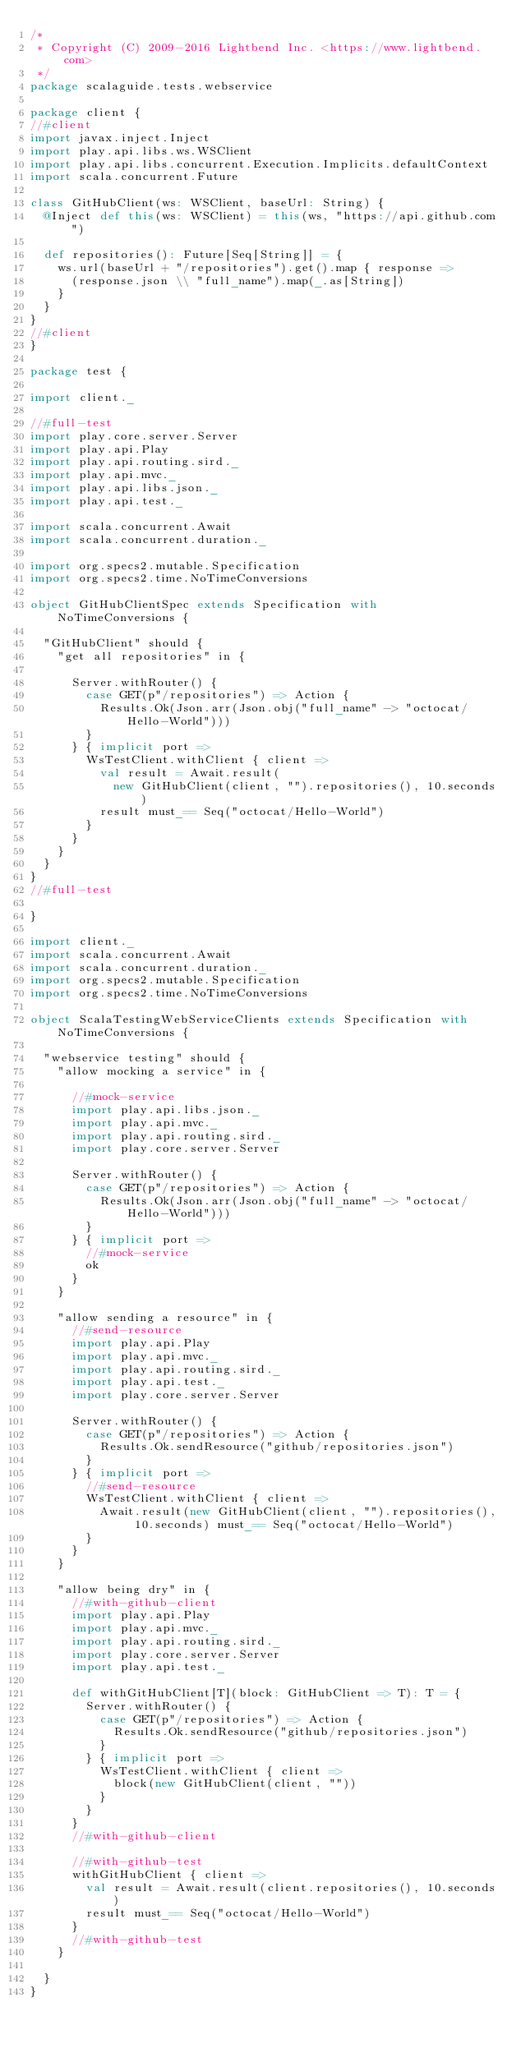<code> <loc_0><loc_0><loc_500><loc_500><_Scala_>/*
 * Copyright (C) 2009-2016 Lightbend Inc. <https://www.lightbend.com>
 */
package scalaguide.tests.webservice

package client {
//#client
import javax.inject.Inject
import play.api.libs.ws.WSClient
import play.api.libs.concurrent.Execution.Implicits.defaultContext
import scala.concurrent.Future

class GitHubClient(ws: WSClient, baseUrl: String) {
  @Inject def this(ws: WSClient) = this(ws, "https://api.github.com")

  def repositories(): Future[Seq[String]] = {
    ws.url(baseUrl + "/repositories").get().map { response =>
      (response.json \\ "full_name").map(_.as[String])
    }
  }
}
//#client
}

package test {

import client._

//#full-test
import play.core.server.Server
import play.api.Play
import play.api.routing.sird._
import play.api.mvc._
import play.api.libs.json._
import play.api.test._

import scala.concurrent.Await
import scala.concurrent.duration._

import org.specs2.mutable.Specification
import org.specs2.time.NoTimeConversions

object GitHubClientSpec extends Specification with NoTimeConversions {

  "GitHubClient" should {
    "get all repositories" in {

      Server.withRouter() {
        case GET(p"/repositories") => Action {
          Results.Ok(Json.arr(Json.obj("full_name" -> "octocat/Hello-World")))
        }
      } { implicit port =>
        WsTestClient.withClient { client =>
          val result = Await.result(
            new GitHubClient(client, "").repositories(), 10.seconds)
          result must_== Seq("octocat/Hello-World")
        }
      }
    }
  }
}
//#full-test

}

import client._
import scala.concurrent.Await
import scala.concurrent.duration._
import org.specs2.mutable.Specification
import org.specs2.time.NoTimeConversions

object ScalaTestingWebServiceClients extends Specification with NoTimeConversions {

  "webservice testing" should {
    "allow mocking a service" in {

      //#mock-service
      import play.api.libs.json._
      import play.api.mvc._
      import play.api.routing.sird._
      import play.core.server.Server

      Server.withRouter() {
        case GET(p"/repositories") => Action {
          Results.Ok(Json.arr(Json.obj("full_name" -> "octocat/Hello-World")))
        }
      } { implicit port =>
        //#mock-service
        ok
      }
    }

    "allow sending a resource" in {
      //#send-resource
      import play.api.Play
      import play.api.mvc._
      import play.api.routing.sird._
      import play.api.test._
      import play.core.server.Server

      Server.withRouter() {
        case GET(p"/repositories") => Action {
          Results.Ok.sendResource("github/repositories.json")
        }
      } { implicit port =>
        //#send-resource
        WsTestClient.withClient { client =>
          Await.result(new GitHubClient(client, "").repositories(), 10.seconds) must_== Seq("octocat/Hello-World")
        }
      }
    }

    "allow being dry" in {
      //#with-github-client
      import play.api.Play
      import play.api.mvc._
      import play.api.routing.sird._
      import play.core.server.Server
      import play.api.test._

      def withGitHubClient[T](block: GitHubClient => T): T = {
        Server.withRouter() {
          case GET(p"/repositories") => Action {
            Results.Ok.sendResource("github/repositories.json")
          }
        } { implicit port =>
          WsTestClient.withClient { client =>
            block(new GitHubClient(client, ""))
          }
        }
      }
      //#with-github-client

      //#with-github-test
      withGitHubClient { client =>
        val result = Await.result(client.repositories(), 10.seconds)
        result must_== Seq("octocat/Hello-World")
      }
      //#with-github-test
    }

  }
}
</code> 